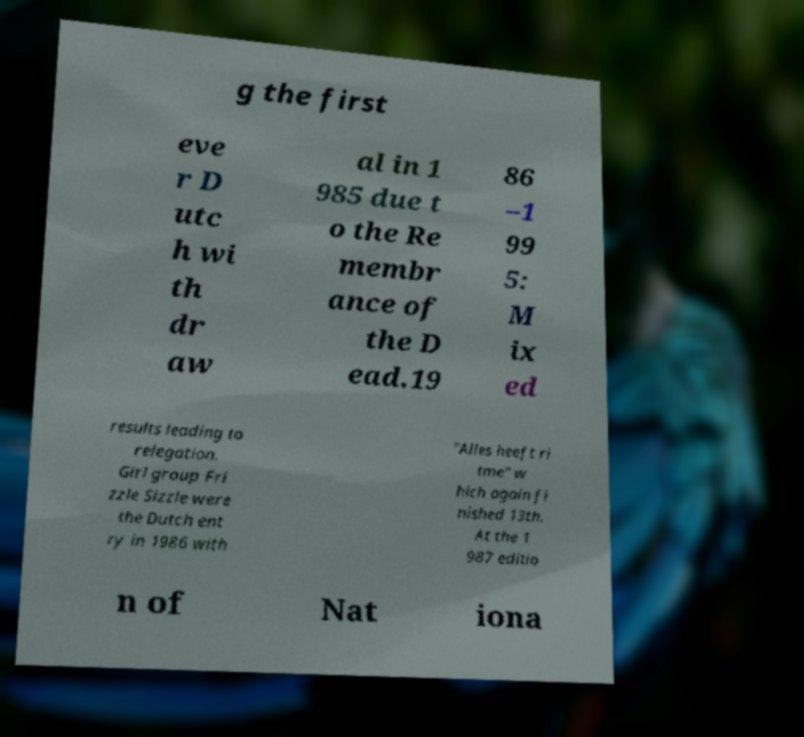I need the written content from this picture converted into text. Can you do that? g the first eve r D utc h wi th dr aw al in 1 985 due t o the Re membr ance of the D ead.19 86 –1 99 5: M ix ed results leading to relegation. Girl group Fri zzle Sizzle were the Dutch ent ry in 1986 with "Alles heeft ri tme" w hich again fi nished 13th. At the 1 987 editio n of Nat iona 